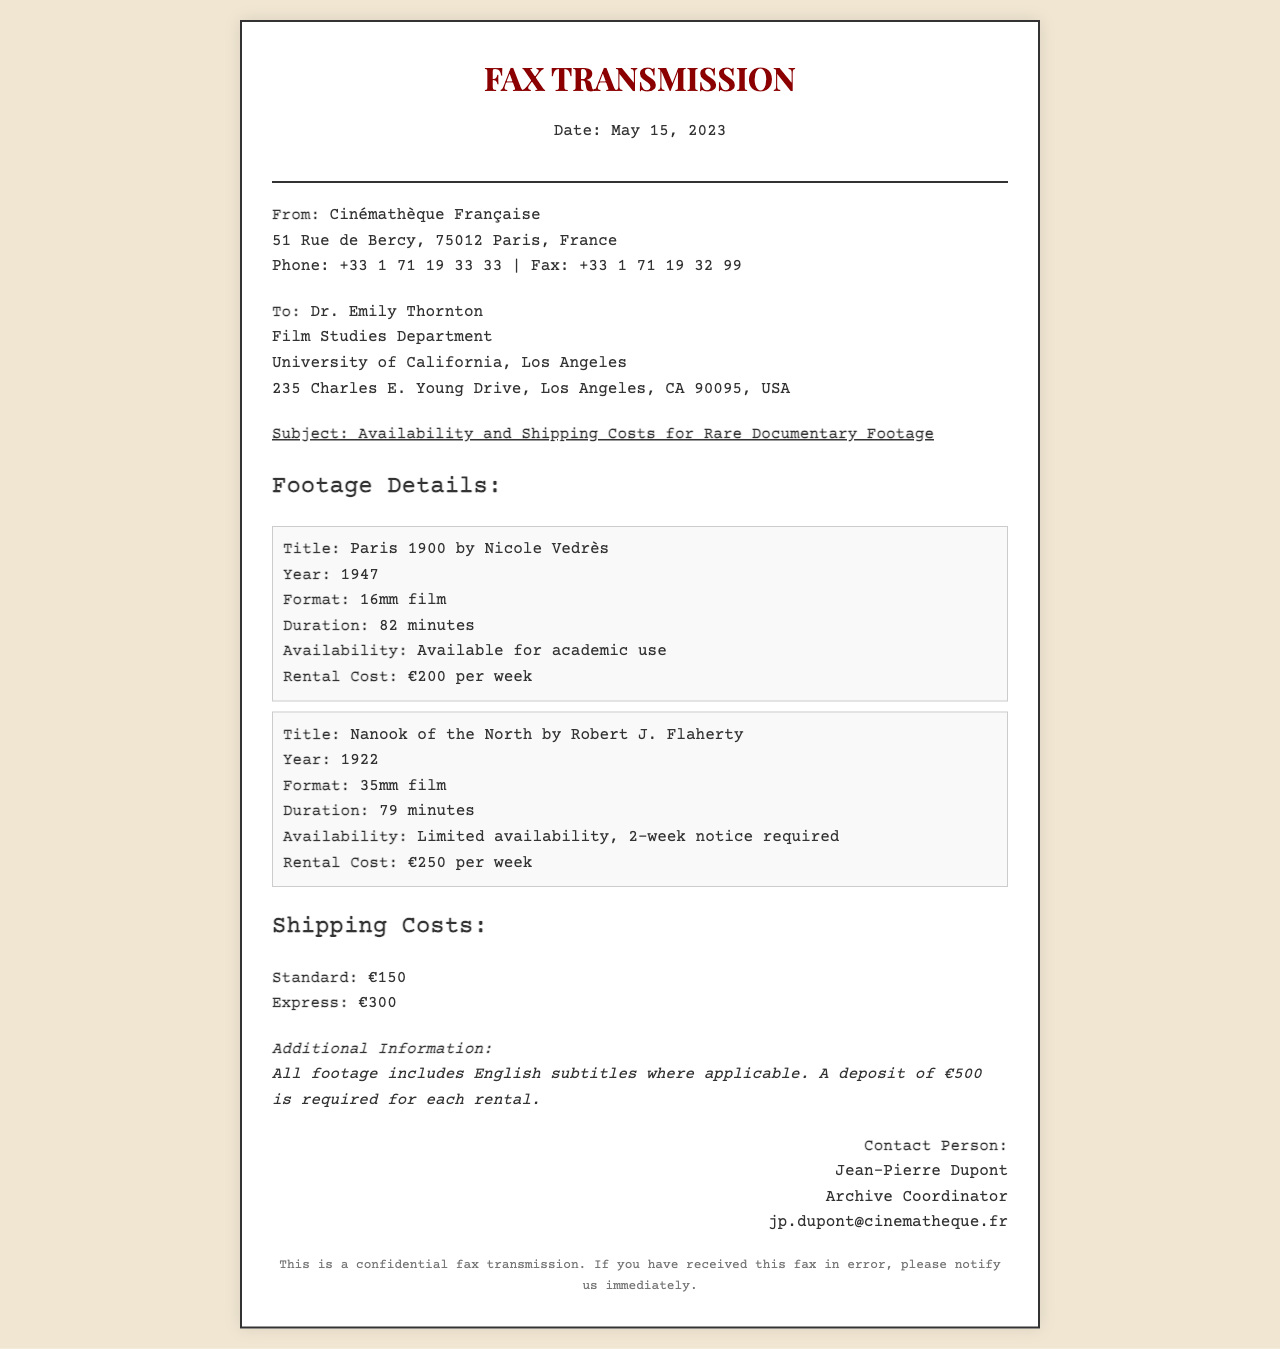What is the title of the first documentary footage? The title of the first documentary footage listed in the document is "Paris 1900 by Nicole Vedrès."
Answer: Paris 1900 by Nicole Vedrès What is the rental cost for "Nanook of the North"? The rental cost for "Nanook of the North" is specified in the document, which states it is €250 per week.
Answer: €250 per week What year was "Paris 1900" released? The document explicitly states the year of release for "Paris 1900," which is 1947.
Answer: 1947 What is the express shipping cost? The document provides the express shipping cost, which is €300.
Answer: €300 How many weeks' notice is required for "Nanook of the North"? According to the document, "Nanook of the North" requires a 2-week notice for rental.
Answer: 2-week notice Who is the contact person for this fax? The document lists the contact person as Jean-Pierre Dupont.
Answer: Jean-Pierre Dupont What is the duration of "Paris 1900"? The duration of "Paris 1900" is mentioned in the document, which states it is 82 minutes long.
Answer: 82 minutes Is English subtitles included with the footage? The document explicitly mentions that all footage includes English subtitles where applicable.
Answer: Yes What is the deposit required for each rental? The document specifies that a deposit of €500 is required for each rental.
Answer: €500 